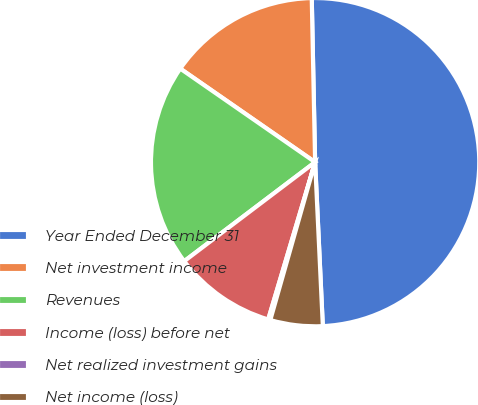Convert chart to OTSL. <chart><loc_0><loc_0><loc_500><loc_500><pie_chart><fcel>Year Ended December 31<fcel>Net investment income<fcel>Revenues<fcel>Income (loss) before net<fcel>Net realized investment gains<fcel>Net income (loss)<nl><fcel>49.58%<fcel>15.02%<fcel>19.96%<fcel>10.08%<fcel>0.21%<fcel>5.15%<nl></chart> 